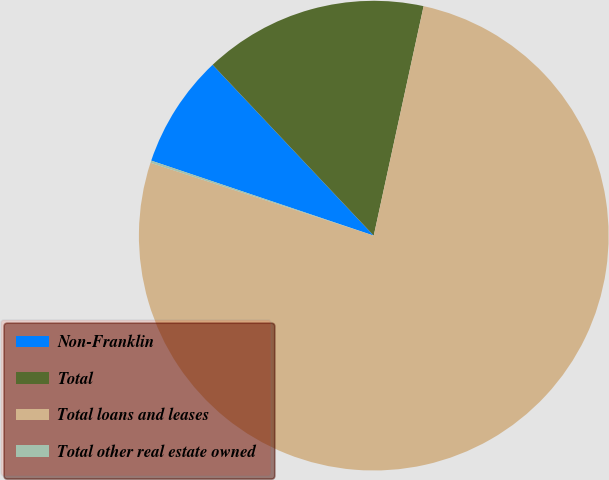Convert chart. <chart><loc_0><loc_0><loc_500><loc_500><pie_chart><fcel>Non-Franklin<fcel>Total<fcel>Total loans and leases<fcel>Total other real estate owned<nl><fcel>7.79%<fcel>15.44%<fcel>76.62%<fcel>0.15%<nl></chart> 